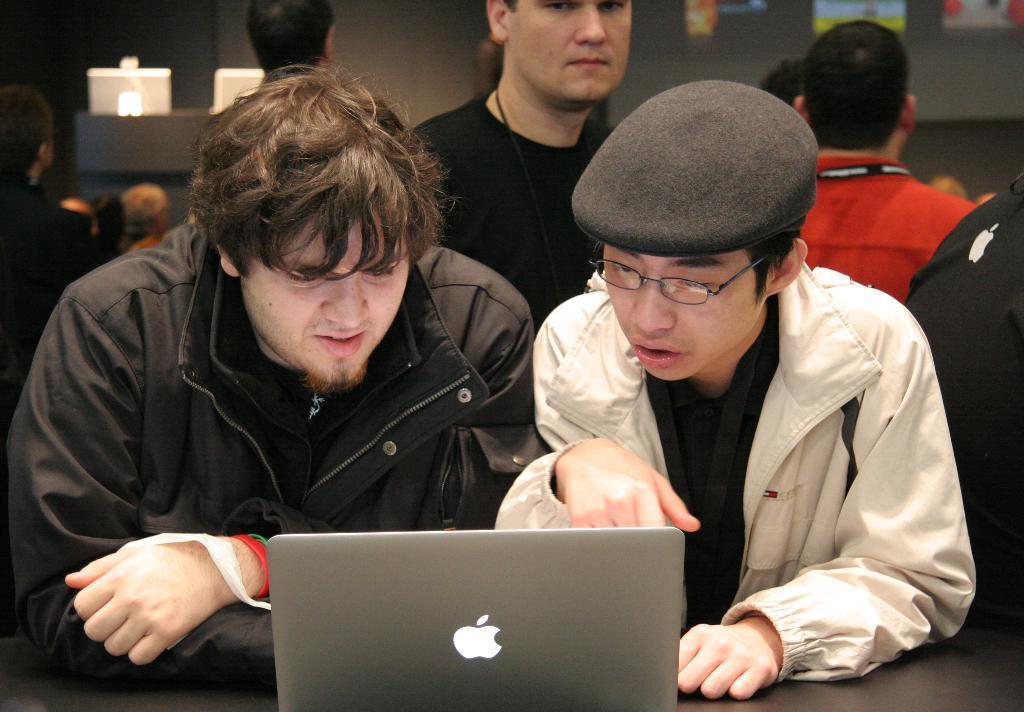How would you summarize this image in a sentence or two? In this image there are people. There are laptops. There is a screen on the backside. 